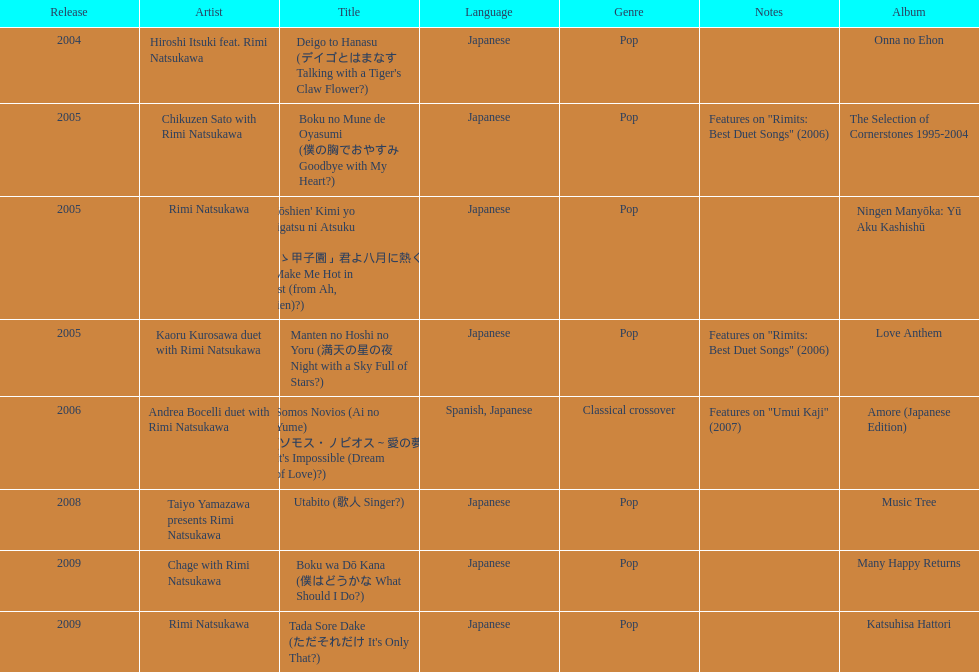What year was the first title released? 2004. 